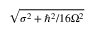<formula> <loc_0><loc_0><loc_500><loc_500>\sqrt { \sigma ^ { 2 } + \hbar { ^ } { 2 } / 1 6 \Omega ^ { 2 } }</formula> 